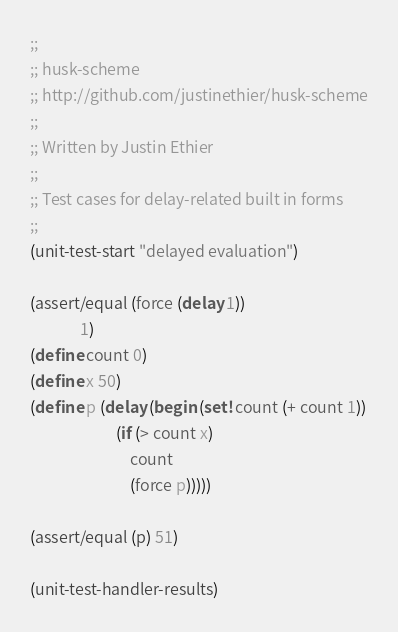<code> <loc_0><loc_0><loc_500><loc_500><_Scheme_>;;
;; husk-scheme
;; http://github.com/justinethier/husk-scheme
;;
;; Written by Justin Ethier
;;
;; Test cases for delay-related built in forms 
;;
(unit-test-start "delayed evaluation")

(assert/equal (force (delay 1))
			  1)
(define count 0)
(define x 50)
(define p (delay (begin (set! count (+ count 1))
                        (if (> count x)
                            count
                            (force p)))))

(assert/equal (p) 51)

(unit-test-handler-results)

</code> 